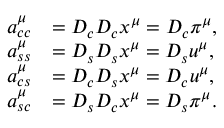<formula> <loc_0><loc_0><loc_500><loc_500>\begin{array} { r l } { a _ { c c } ^ { \mu } } & { = D _ { c } D _ { c } x ^ { \mu } = D _ { c } \pi ^ { \mu } , } \\ { a _ { s s } ^ { \mu } } & { = D _ { s } D _ { s } x ^ { \mu } = D _ { s } u ^ { \mu } , } \\ { a _ { c s } ^ { \mu } } & { = D _ { c } D _ { s } x ^ { \mu } = D _ { c } u ^ { \mu } , } \\ { a _ { s c } ^ { \mu } } & { = D _ { s } D _ { c } x ^ { \mu } = D _ { s } \pi ^ { \mu } . } \end{array}</formula> 